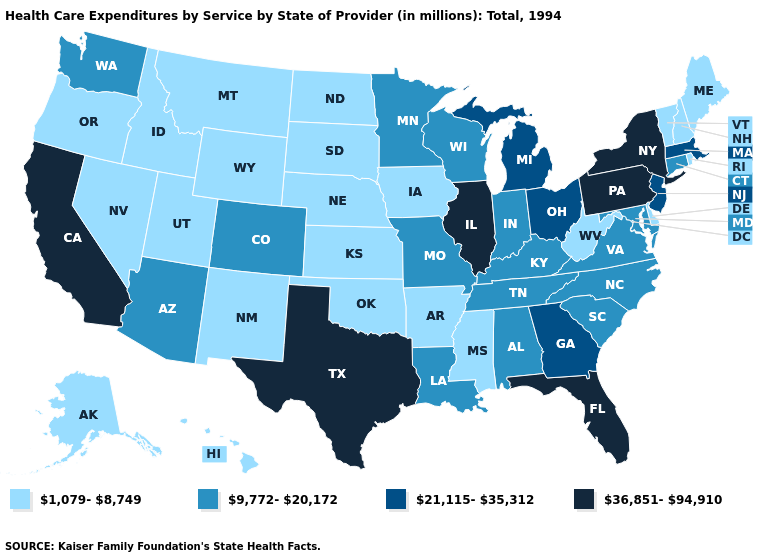What is the value of Vermont?
Quick response, please. 1,079-8,749. What is the highest value in the Northeast ?
Keep it brief. 36,851-94,910. What is the value of Ohio?
Be succinct. 21,115-35,312. Among the states that border New Hampshire , which have the lowest value?
Quick response, please. Maine, Vermont. Name the states that have a value in the range 1,079-8,749?
Answer briefly. Alaska, Arkansas, Delaware, Hawaii, Idaho, Iowa, Kansas, Maine, Mississippi, Montana, Nebraska, Nevada, New Hampshire, New Mexico, North Dakota, Oklahoma, Oregon, Rhode Island, South Dakota, Utah, Vermont, West Virginia, Wyoming. Name the states that have a value in the range 21,115-35,312?
Keep it brief. Georgia, Massachusetts, Michigan, New Jersey, Ohio. Does the map have missing data?
Write a very short answer. No. Name the states that have a value in the range 9,772-20,172?
Quick response, please. Alabama, Arizona, Colorado, Connecticut, Indiana, Kentucky, Louisiana, Maryland, Minnesota, Missouri, North Carolina, South Carolina, Tennessee, Virginia, Washington, Wisconsin. What is the lowest value in the South?
Keep it brief. 1,079-8,749. Does the first symbol in the legend represent the smallest category?
Short answer required. Yes. Does the map have missing data?
Short answer required. No. Among the states that border Delaware , does Maryland have the lowest value?
Keep it brief. Yes. Among the states that border Missouri , does Tennessee have the lowest value?
Write a very short answer. No. 